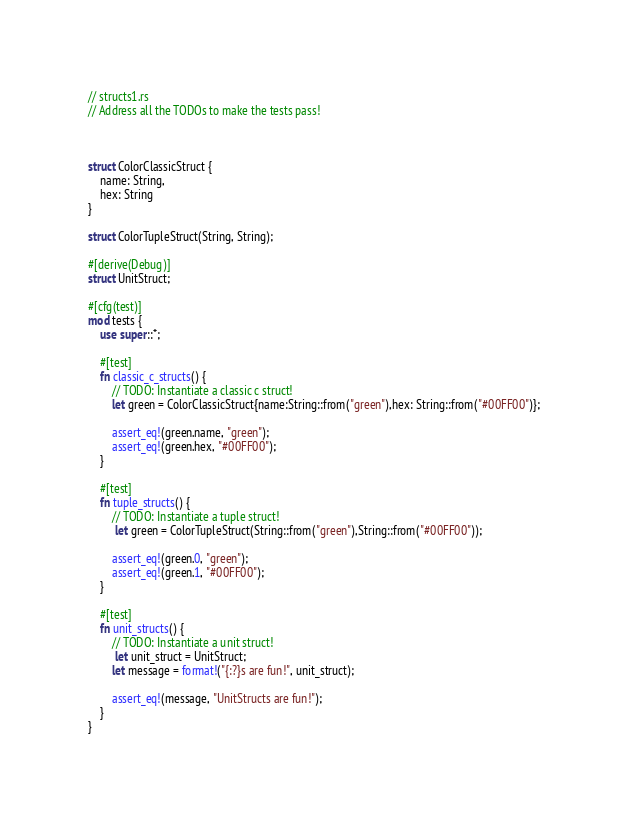Convert code to text. <code><loc_0><loc_0><loc_500><loc_500><_Rust_>// structs1.rs
// Address all the TODOs to make the tests pass!



struct ColorClassicStruct {
    name: String,
    hex: String
}

struct ColorTupleStruct(String, String);

#[derive(Debug)]
struct UnitStruct;

#[cfg(test)]
mod tests {
    use super::*;

    #[test]
    fn classic_c_structs() {
        // TODO: Instantiate a classic c struct!
        let green = ColorClassicStruct{name:String::from("green"),hex: String::from("#00FF00")};

        assert_eq!(green.name, "green");
        assert_eq!(green.hex, "#00FF00");
    }

    #[test]
    fn tuple_structs() {
        // TODO: Instantiate a tuple struct!
         let green = ColorTupleStruct(String::from("green"),String::from("#00FF00"));

        assert_eq!(green.0, "green");
        assert_eq!(green.1, "#00FF00");
    }

    #[test]
    fn unit_structs() {
        // TODO: Instantiate a unit struct!
         let unit_struct = UnitStruct;
        let message = format!("{:?}s are fun!", unit_struct);

        assert_eq!(message, "UnitStructs are fun!");
    }
}
</code> 